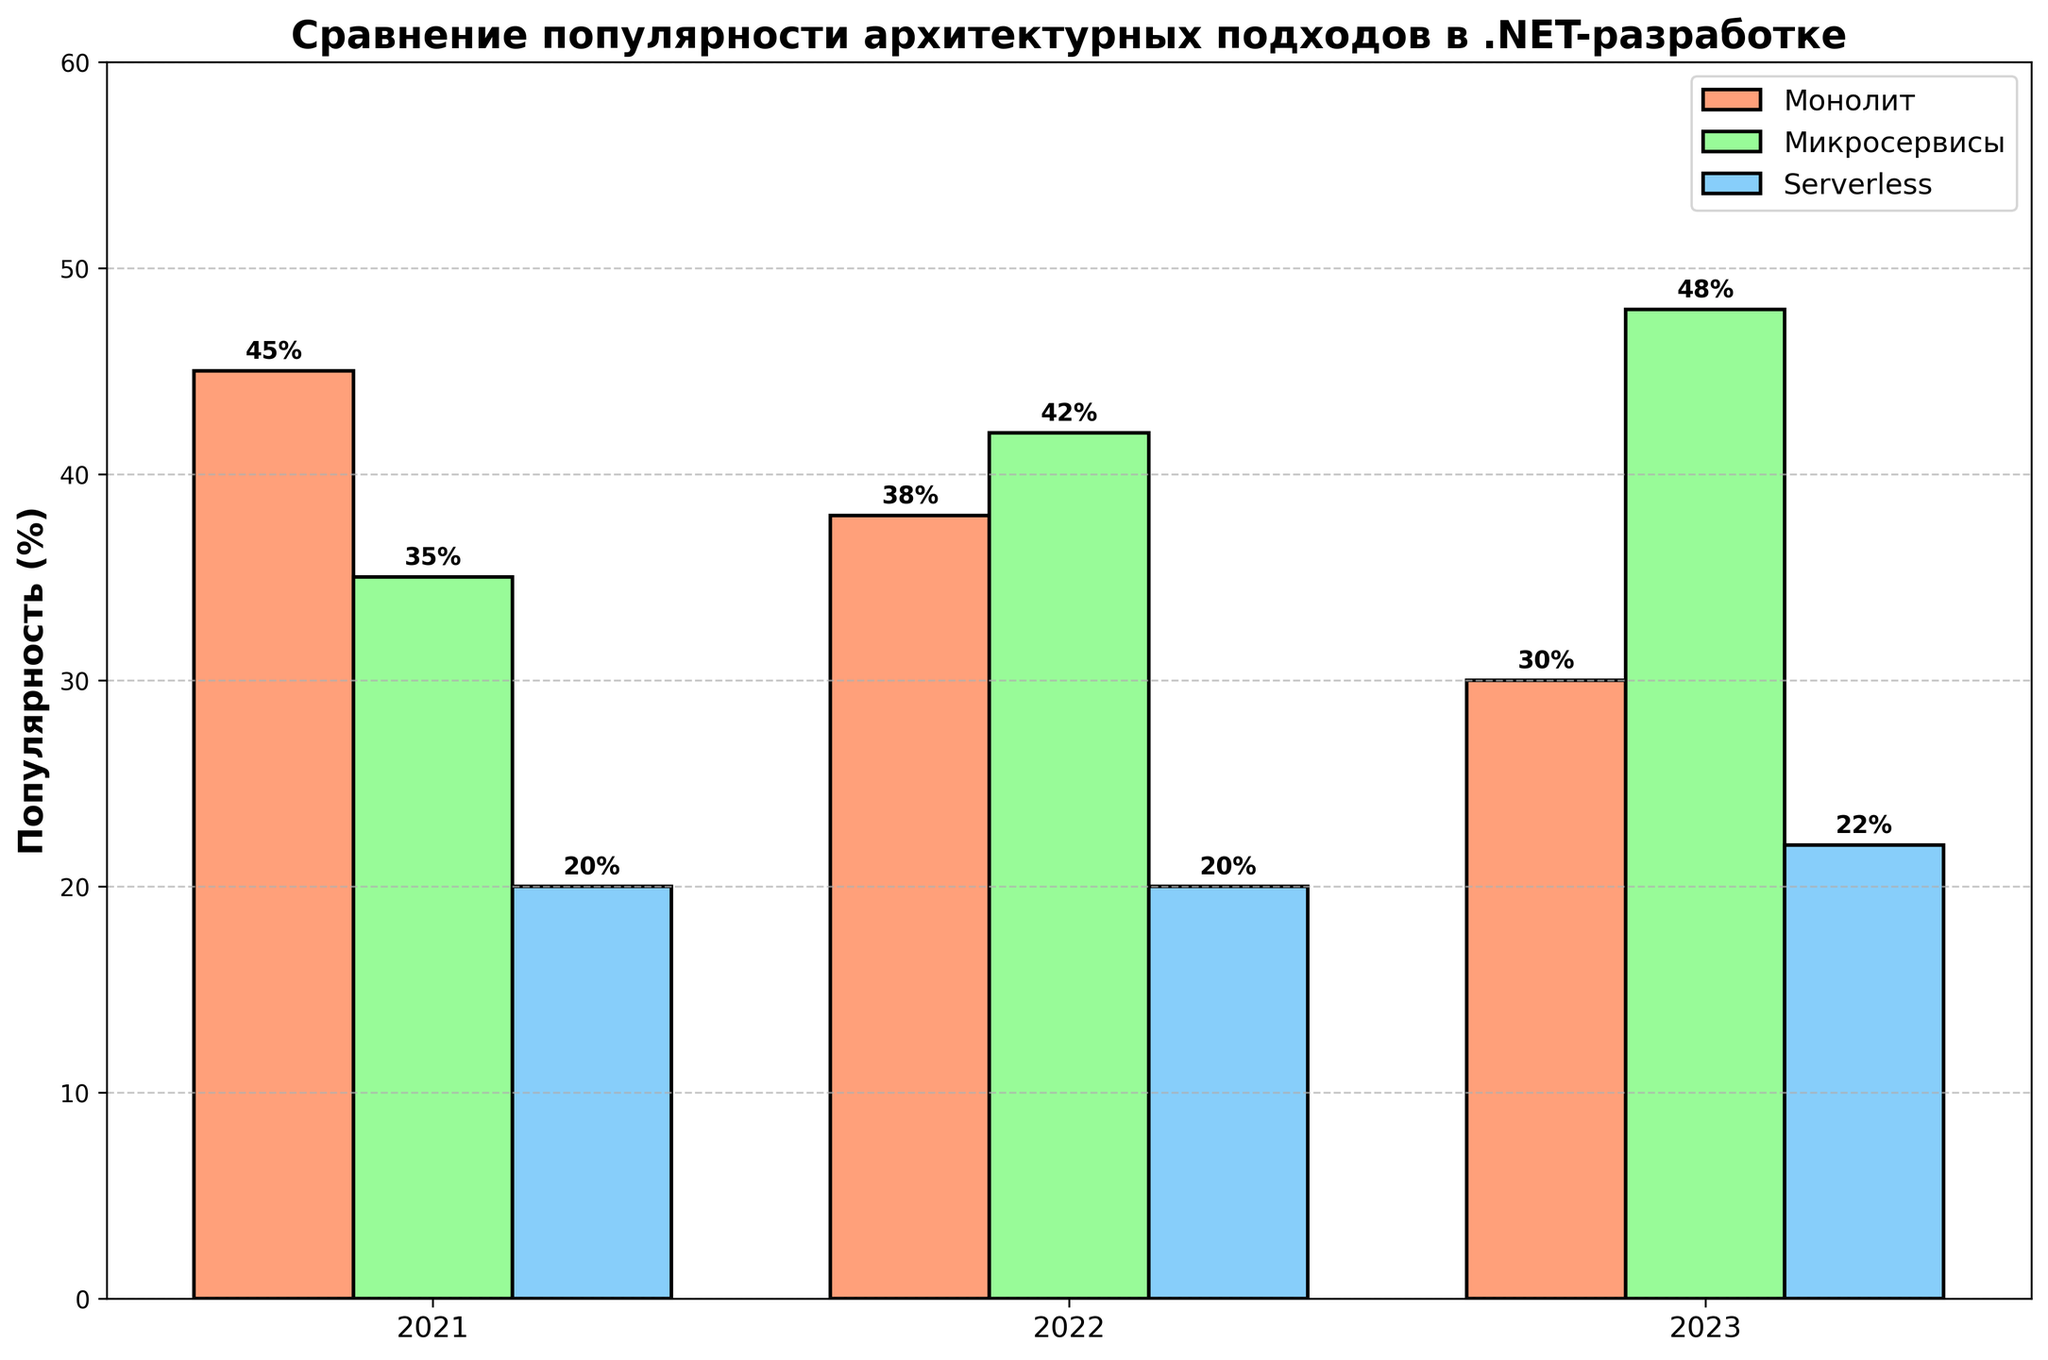Which architectural approach saw a decline in popularity each year? We observe that the Monolith approach had 45% popularity in 2021, 38% in 2022, and 30% in 2023. Therefore, its popularity decreased annually.
Answer: Monolith Which architectural approach gained the most popularity from 2021 to 2023? The Microservices approach increased from 35% in 2021 to 48% in 2023, a gain of 13%, which is higher than the changes observed in other approaches.
Answer: Microservices In which year was the Serverless approach the least popular? Referring to the bars representing Serverless across the years, we see that it was least popular in 2021 with 20% popularity, remaining steady in 2022, and slightly increasing in 2023.
Answer: 2021 Which architectural approach had the highest percentage in any given year? Examining the heights of bars across all years, the Microservices approach in 2023 had the highest percentage at 48%.
Answer: Microservices in 2023 Compare the combined popularity of Monolith and Serverless in 2023. Is it more than the popularity of Microservices in the same year? For 2023, the Monolith and Serverless approaches have 30% and 22% popularity, respectively. The combined percentage is 30% + 22% = 52%, which is more than the 48% for Microservices in 2023.
Answer: Yes Which approach maintained a steady percentage from 2021 to 2022? The Serverless approach had 20% popularity in both 2021 and 2022, indicating it remained steady.
Answer: Serverless What is the average popularity of the Microservices approach over the three years? Adding the Microservices percentages for the three years: 35% (2021) + 42% (2022) + 48% (2023) = 125%. Dividing by 3 gives the average: 125% / 3 ≈ 41.67%.
Answer: 41.67% Which year had the highest total combined popularity for all three architectural approaches? Summing up the popularity percentages for each year: 2021 (45 + 35 + 20 = 100), 2022 (38 + 42 + 20 = 100), 2023 (30 + 48 + 22 = 100). All years have a total of 100%.
Answer: All years have the highest combined popularity equally When comparing the popularity of Monolith and Microservices in 2021, which was more popular and by how much? The Monolith had a 45% popularity, whereas Microservices had 35% in 2021. The difference is 45% - 35% = 10%.
Answer: Monolith by 10% Which year saw the same level of popularity for the Serverless approach? The Serverless approach had 20% popularity in both 2021 and 2022.
Answer: 2021 and 2022 